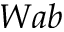<formula> <loc_0><loc_0><loc_500><loc_500>W a b</formula> 